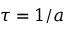Convert formula to latex. <formula><loc_0><loc_0><loc_500><loc_500>\tau = 1 / a</formula> 